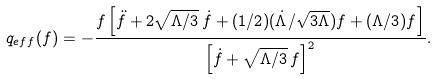<formula> <loc_0><loc_0><loc_500><loc_500>q _ { e f f } ( f ) = - \frac { f \left [ \ddot { f } + 2 \sqrt { \Lambda / 3 } \, \dot { f } + ( 1 / 2 ) ( \dot { \Lambda } / \sqrt { 3 \Lambda } ) f + ( \Lambda / 3 ) f \right ] } { \left [ \dot { f } + \sqrt { \Lambda / 3 } \, f \right ] ^ { 2 } } .</formula> 